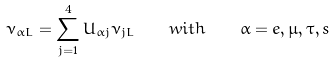<formula> <loc_0><loc_0><loc_500><loc_500>\nu _ { \alpha L } = \sum _ { j = 1 } ^ { 4 } U _ { \alpha j } \nu _ { j L } \quad w i t h \quad \alpha = e , \mu , \tau , s</formula> 